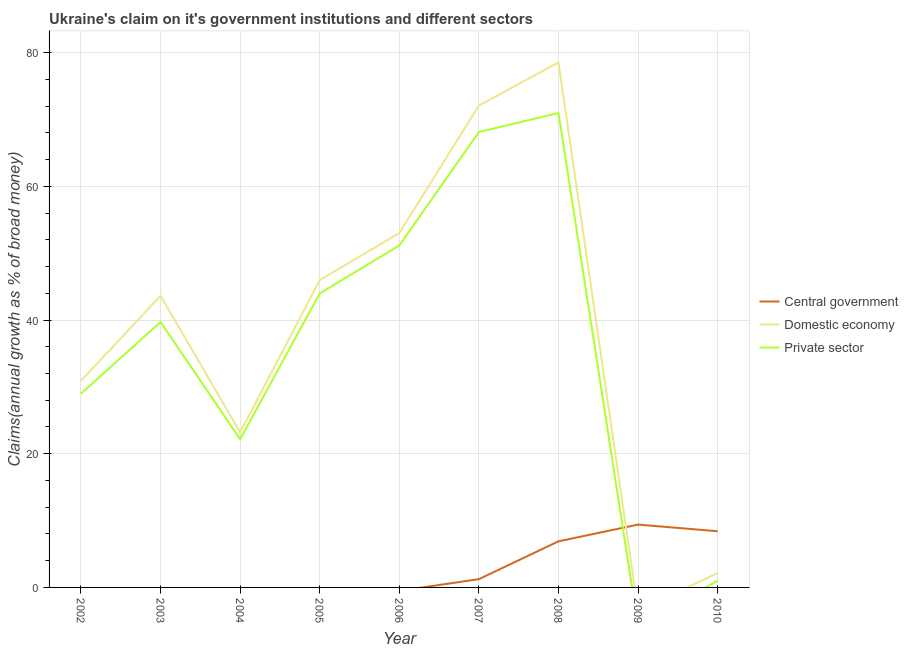How many different coloured lines are there?
Give a very brief answer. 3. Is the number of lines equal to the number of legend labels?
Your response must be concise. No. What is the percentage of claim on the private sector in 2008?
Provide a short and direct response. 70.97. Across all years, what is the maximum percentage of claim on the private sector?
Your response must be concise. 70.97. Across all years, what is the minimum percentage of claim on the central government?
Your answer should be compact. 0. In which year was the percentage of claim on the central government maximum?
Keep it short and to the point. 2009. What is the total percentage of claim on the private sector in the graph?
Offer a terse response. 326.09. What is the difference between the percentage of claim on the private sector in 2004 and that in 2008?
Offer a very short reply. -48.8. What is the difference between the percentage of claim on the central government in 2004 and the percentage of claim on the private sector in 2003?
Your answer should be compact. -39.7. What is the average percentage of claim on the central government per year?
Provide a short and direct response. 2.88. In the year 2008, what is the difference between the percentage of claim on the private sector and percentage of claim on the central government?
Make the answer very short. 64.07. In how many years, is the percentage of claim on the private sector greater than 44 %?
Provide a short and direct response. 3. What is the ratio of the percentage of claim on the domestic economy in 2002 to that in 2006?
Keep it short and to the point. 0.58. Is the percentage of claim on the private sector in 2003 less than that in 2004?
Offer a very short reply. No. Is the difference between the percentage of claim on the private sector in 2003 and 2005 greater than the difference between the percentage of claim on the domestic economy in 2003 and 2005?
Your response must be concise. No. What is the difference between the highest and the second highest percentage of claim on the private sector?
Provide a short and direct response. 2.84. What is the difference between the highest and the lowest percentage of claim on the private sector?
Offer a terse response. 70.97. In how many years, is the percentage of claim on the private sector greater than the average percentage of claim on the private sector taken over all years?
Make the answer very short. 5. Is it the case that in every year, the sum of the percentage of claim on the central government and percentage of claim on the domestic economy is greater than the percentage of claim on the private sector?
Ensure brevity in your answer.  Yes. How many lines are there?
Your answer should be very brief. 3. What is the difference between two consecutive major ticks on the Y-axis?
Ensure brevity in your answer.  20. Does the graph contain any zero values?
Offer a very short reply. Yes. How many legend labels are there?
Offer a terse response. 3. What is the title of the graph?
Make the answer very short. Ukraine's claim on it's government institutions and different sectors. What is the label or title of the Y-axis?
Your answer should be very brief. Claims(annual growth as % of broad money). What is the Claims(annual growth as % of broad money) of Domestic economy in 2002?
Keep it short and to the point. 30.9. What is the Claims(annual growth as % of broad money) in Private sector in 2002?
Provide a succinct answer. 28.98. What is the Claims(annual growth as % of broad money) of Central government in 2003?
Your answer should be very brief. 0. What is the Claims(annual growth as % of broad money) in Domestic economy in 2003?
Give a very brief answer. 43.63. What is the Claims(annual growth as % of broad money) of Private sector in 2003?
Your answer should be very brief. 39.7. What is the Claims(annual growth as % of broad money) in Central government in 2004?
Keep it short and to the point. 0. What is the Claims(annual growth as % of broad money) of Domestic economy in 2004?
Provide a short and direct response. 23.21. What is the Claims(annual growth as % of broad money) of Private sector in 2004?
Make the answer very short. 22.17. What is the Claims(annual growth as % of broad money) of Central government in 2005?
Keep it short and to the point. 0. What is the Claims(annual growth as % of broad money) of Domestic economy in 2005?
Ensure brevity in your answer.  45.97. What is the Claims(annual growth as % of broad money) of Private sector in 2005?
Offer a very short reply. 43.97. What is the Claims(annual growth as % of broad money) of Domestic economy in 2006?
Provide a short and direct response. 53. What is the Claims(annual growth as % of broad money) in Private sector in 2006?
Offer a terse response. 51.15. What is the Claims(annual growth as % of broad money) in Central government in 2007?
Your response must be concise. 1.24. What is the Claims(annual growth as % of broad money) in Domestic economy in 2007?
Offer a very short reply. 72.08. What is the Claims(annual growth as % of broad money) in Private sector in 2007?
Offer a terse response. 68.12. What is the Claims(annual growth as % of broad money) in Central government in 2008?
Your answer should be compact. 6.9. What is the Claims(annual growth as % of broad money) of Domestic economy in 2008?
Make the answer very short. 78.53. What is the Claims(annual growth as % of broad money) of Private sector in 2008?
Give a very brief answer. 70.97. What is the Claims(annual growth as % of broad money) of Central government in 2009?
Give a very brief answer. 9.4. What is the Claims(annual growth as % of broad money) of Private sector in 2009?
Your answer should be compact. 0. What is the Claims(annual growth as % of broad money) in Central government in 2010?
Ensure brevity in your answer.  8.4. What is the Claims(annual growth as % of broad money) of Domestic economy in 2010?
Provide a succinct answer. 2.14. What is the Claims(annual growth as % of broad money) in Private sector in 2010?
Offer a very short reply. 1.02. Across all years, what is the maximum Claims(annual growth as % of broad money) of Central government?
Offer a terse response. 9.4. Across all years, what is the maximum Claims(annual growth as % of broad money) in Domestic economy?
Offer a very short reply. 78.53. Across all years, what is the maximum Claims(annual growth as % of broad money) of Private sector?
Offer a terse response. 70.97. Across all years, what is the minimum Claims(annual growth as % of broad money) in Domestic economy?
Make the answer very short. 0. Across all years, what is the minimum Claims(annual growth as % of broad money) of Private sector?
Keep it short and to the point. 0. What is the total Claims(annual growth as % of broad money) of Central government in the graph?
Your answer should be compact. 25.94. What is the total Claims(annual growth as % of broad money) of Domestic economy in the graph?
Give a very brief answer. 349.46. What is the total Claims(annual growth as % of broad money) in Private sector in the graph?
Your response must be concise. 326.09. What is the difference between the Claims(annual growth as % of broad money) in Domestic economy in 2002 and that in 2003?
Provide a short and direct response. -12.72. What is the difference between the Claims(annual growth as % of broad money) of Private sector in 2002 and that in 2003?
Give a very brief answer. -10.72. What is the difference between the Claims(annual growth as % of broad money) in Domestic economy in 2002 and that in 2004?
Make the answer very short. 7.69. What is the difference between the Claims(annual growth as % of broad money) in Private sector in 2002 and that in 2004?
Provide a succinct answer. 6.82. What is the difference between the Claims(annual growth as % of broad money) of Domestic economy in 2002 and that in 2005?
Ensure brevity in your answer.  -15.06. What is the difference between the Claims(annual growth as % of broad money) of Private sector in 2002 and that in 2005?
Your response must be concise. -14.99. What is the difference between the Claims(annual growth as % of broad money) in Domestic economy in 2002 and that in 2006?
Your response must be concise. -22.1. What is the difference between the Claims(annual growth as % of broad money) of Private sector in 2002 and that in 2006?
Ensure brevity in your answer.  -22.17. What is the difference between the Claims(annual growth as % of broad money) in Domestic economy in 2002 and that in 2007?
Give a very brief answer. -41.18. What is the difference between the Claims(annual growth as % of broad money) in Private sector in 2002 and that in 2007?
Provide a succinct answer. -39.14. What is the difference between the Claims(annual growth as % of broad money) in Domestic economy in 2002 and that in 2008?
Provide a short and direct response. -47.62. What is the difference between the Claims(annual growth as % of broad money) of Private sector in 2002 and that in 2008?
Provide a short and direct response. -41.99. What is the difference between the Claims(annual growth as % of broad money) of Domestic economy in 2002 and that in 2010?
Your response must be concise. 28.76. What is the difference between the Claims(annual growth as % of broad money) in Private sector in 2002 and that in 2010?
Give a very brief answer. 27.96. What is the difference between the Claims(annual growth as % of broad money) in Domestic economy in 2003 and that in 2004?
Your response must be concise. 20.41. What is the difference between the Claims(annual growth as % of broad money) in Private sector in 2003 and that in 2004?
Your answer should be compact. 17.53. What is the difference between the Claims(annual growth as % of broad money) of Domestic economy in 2003 and that in 2005?
Ensure brevity in your answer.  -2.34. What is the difference between the Claims(annual growth as % of broad money) of Private sector in 2003 and that in 2005?
Offer a terse response. -4.27. What is the difference between the Claims(annual growth as % of broad money) in Domestic economy in 2003 and that in 2006?
Make the answer very short. -9.38. What is the difference between the Claims(annual growth as % of broad money) of Private sector in 2003 and that in 2006?
Make the answer very short. -11.45. What is the difference between the Claims(annual growth as % of broad money) in Domestic economy in 2003 and that in 2007?
Offer a terse response. -28.45. What is the difference between the Claims(annual growth as % of broad money) of Private sector in 2003 and that in 2007?
Make the answer very short. -28.42. What is the difference between the Claims(annual growth as % of broad money) of Domestic economy in 2003 and that in 2008?
Offer a very short reply. -34.9. What is the difference between the Claims(annual growth as % of broad money) in Private sector in 2003 and that in 2008?
Provide a succinct answer. -31.27. What is the difference between the Claims(annual growth as % of broad money) in Domestic economy in 2003 and that in 2010?
Your answer should be compact. 41.49. What is the difference between the Claims(annual growth as % of broad money) in Private sector in 2003 and that in 2010?
Ensure brevity in your answer.  38.68. What is the difference between the Claims(annual growth as % of broad money) in Domestic economy in 2004 and that in 2005?
Your answer should be very brief. -22.75. What is the difference between the Claims(annual growth as % of broad money) in Private sector in 2004 and that in 2005?
Offer a terse response. -21.81. What is the difference between the Claims(annual growth as % of broad money) of Domestic economy in 2004 and that in 2006?
Keep it short and to the point. -29.79. What is the difference between the Claims(annual growth as % of broad money) in Private sector in 2004 and that in 2006?
Your response must be concise. -28.98. What is the difference between the Claims(annual growth as % of broad money) in Domestic economy in 2004 and that in 2007?
Offer a very short reply. -48.86. What is the difference between the Claims(annual growth as % of broad money) of Private sector in 2004 and that in 2007?
Make the answer very short. -45.96. What is the difference between the Claims(annual growth as % of broad money) of Domestic economy in 2004 and that in 2008?
Make the answer very short. -55.31. What is the difference between the Claims(annual growth as % of broad money) of Private sector in 2004 and that in 2008?
Provide a succinct answer. -48.8. What is the difference between the Claims(annual growth as % of broad money) of Domestic economy in 2004 and that in 2010?
Ensure brevity in your answer.  21.07. What is the difference between the Claims(annual growth as % of broad money) in Private sector in 2004 and that in 2010?
Ensure brevity in your answer.  21.15. What is the difference between the Claims(annual growth as % of broad money) of Domestic economy in 2005 and that in 2006?
Make the answer very short. -7.04. What is the difference between the Claims(annual growth as % of broad money) of Private sector in 2005 and that in 2006?
Offer a terse response. -7.17. What is the difference between the Claims(annual growth as % of broad money) of Domestic economy in 2005 and that in 2007?
Your response must be concise. -26.11. What is the difference between the Claims(annual growth as % of broad money) of Private sector in 2005 and that in 2007?
Provide a short and direct response. -24.15. What is the difference between the Claims(annual growth as % of broad money) of Domestic economy in 2005 and that in 2008?
Ensure brevity in your answer.  -32.56. What is the difference between the Claims(annual growth as % of broad money) in Private sector in 2005 and that in 2008?
Provide a short and direct response. -26.99. What is the difference between the Claims(annual growth as % of broad money) in Domestic economy in 2005 and that in 2010?
Keep it short and to the point. 43.83. What is the difference between the Claims(annual growth as % of broad money) of Private sector in 2005 and that in 2010?
Give a very brief answer. 42.96. What is the difference between the Claims(annual growth as % of broad money) in Domestic economy in 2006 and that in 2007?
Ensure brevity in your answer.  -19.07. What is the difference between the Claims(annual growth as % of broad money) in Private sector in 2006 and that in 2007?
Your answer should be compact. -16.97. What is the difference between the Claims(annual growth as % of broad money) in Domestic economy in 2006 and that in 2008?
Make the answer very short. -25.52. What is the difference between the Claims(annual growth as % of broad money) in Private sector in 2006 and that in 2008?
Your answer should be compact. -19.82. What is the difference between the Claims(annual growth as % of broad money) in Domestic economy in 2006 and that in 2010?
Your response must be concise. 50.87. What is the difference between the Claims(annual growth as % of broad money) in Private sector in 2006 and that in 2010?
Provide a succinct answer. 50.13. What is the difference between the Claims(annual growth as % of broad money) of Central government in 2007 and that in 2008?
Offer a very short reply. -5.66. What is the difference between the Claims(annual growth as % of broad money) of Domestic economy in 2007 and that in 2008?
Offer a very short reply. -6.45. What is the difference between the Claims(annual growth as % of broad money) in Private sector in 2007 and that in 2008?
Your answer should be very brief. -2.84. What is the difference between the Claims(annual growth as % of broad money) of Central government in 2007 and that in 2009?
Ensure brevity in your answer.  -8.16. What is the difference between the Claims(annual growth as % of broad money) in Central government in 2007 and that in 2010?
Offer a very short reply. -7.17. What is the difference between the Claims(annual growth as % of broad money) of Domestic economy in 2007 and that in 2010?
Give a very brief answer. 69.94. What is the difference between the Claims(annual growth as % of broad money) of Private sector in 2007 and that in 2010?
Offer a very short reply. 67.11. What is the difference between the Claims(annual growth as % of broad money) of Central government in 2008 and that in 2009?
Offer a very short reply. -2.51. What is the difference between the Claims(annual growth as % of broad money) in Central government in 2008 and that in 2010?
Offer a terse response. -1.51. What is the difference between the Claims(annual growth as % of broad money) of Domestic economy in 2008 and that in 2010?
Offer a terse response. 76.39. What is the difference between the Claims(annual growth as % of broad money) of Private sector in 2008 and that in 2010?
Your answer should be compact. 69.95. What is the difference between the Claims(annual growth as % of broad money) of Central government in 2009 and that in 2010?
Your answer should be very brief. 1. What is the difference between the Claims(annual growth as % of broad money) of Domestic economy in 2002 and the Claims(annual growth as % of broad money) of Private sector in 2003?
Offer a very short reply. -8.8. What is the difference between the Claims(annual growth as % of broad money) in Domestic economy in 2002 and the Claims(annual growth as % of broad money) in Private sector in 2004?
Your response must be concise. 8.74. What is the difference between the Claims(annual growth as % of broad money) in Domestic economy in 2002 and the Claims(annual growth as % of broad money) in Private sector in 2005?
Provide a short and direct response. -13.07. What is the difference between the Claims(annual growth as % of broad money) in Domestic economy in 2002 and the Claims(annual growth as % of broad money) in Private sector in 2006?
Keep it short and to the point. -20.25. What is the difference between the Claims(annual growth as % of broad money) in Domestic economy in 2002 and the Claims(annual growth as % of broad money) in Private sector in 2007?
Offer a very short reply. -37.22. What is the difference between the Claims(annual growth as % of broad money) of Domestic economy in 2002 and the Claims(annual growth as % of broad money) of Private sector in 2008?
Make the answer very short. -40.07. What is the difference between the Claims(annual growth as % of broad money) of Domestic economy in 2002 and the Claims(annual growth as % of broad money) of Private sector in 2010?
Offer a terse response. 29.88. What is the difference between the Claims(annual growth as % of broad money) in Domestic economy in 2003 and the Claims(annual growth as % of broad money) in Private sector in 2004?
Offer a very short reply. 21.46. What is the difference between the Claims(annual growth as % of broad money) in Domestic economy in 2003 and the Claims(annual growth as % of broad money) in Private sector in 2005?
Your answer should be compact. -0.35. What is the difference between the Claims(annual growth as % of broad money) in Domestic economy in 2003 and the Claims(annual growth as % of broad money) in Private sector in 2006?
Offer a very short reply. -7.52. What is the difference between the Claims(annual growth as % of broad money) of Domestic economy in 2003 and the Claims(annual growth as % of broad money) of Private sector in 2007?
Give a very brief answer. -24.5. What is the difference between the Claims(annual growth as % of broad money) of Domestic economy in 2003 and the Claims(annual growth as % of broad money) of Private sector in 2008?
Give a very brief answer. -27.34. What is the difference between the Claims(annual growth as % of broad money) of Domestic economy in 2003 and the Claims(annual growth as % of broad money) of Private sector in 2010?
Offer a terse response. 42.61. What is the difference between the Claims(annual growth as % of broad money) of Domestic economy in 2004 and the Claims(annual growth as % of broad money) of Private sector in 2005?
Your response must be concise. -20.76. What is the difference between the Claims(annual growth as % of broad money) of Domestic economy in 2004 and the Claims(annual growth as % of broad money) of Private sector in 2006?
Make the answer very short. -27.94. What is the difference between the Claims(annual growth as % of broad money) of Domestic economy in 2004 and the Claims(annual growth as % of broad money) of Private sector in 2007?
Give a very brief answer. -44.91. What is the difference between the Claims(annual growth as % of broad money) in Domestic economy in 2004 and the Claims(annual growth as % of broad money) in Private sector in 2008?
Offer a terse response. -47.75. What is the difference between the Claims(annual growth as % of broad money) in Domestic economy in 2004 and the Claims(annual growth as % of broad money) in Private sector in 2010?
Ensure brevity in your answer.  22.2. What is the difference between the Claims(annual growth as % of broad money) in Domestic economy in 2005 and the Claims(annual growth as % of broad money) in Private sector in 2006?
Ensure brevity in your answer.  -5.18. What is the difference between the Claims(annual growth as % of broad money) of Domestic economy in 2005 and the Claims(annual growth as % of broad money) of Private sector in 2007?
Offer a very short reply. -22.16. What is the difference between the Claims(annual growth as % of broad money) in Domestic economy in 2005 and the Claims(annual growth as % of broad money) in Private sector in 2008?
Your answer should be compact. -25. What is the difference between the Claims(annual growth as % of broad money) in Domestic economy in 2005 and the Claims(annual growth as % of broad money) in Private sector in 2010?
Keep it short and to the point. 44.95. What is the difference between the Claims(annual growth as % of broad money) in Domestic economy in 2006 and the Claims(annual growth as % of broad money) in Private sector in 2007?
Your answer should be compact. -15.12. What is the difference between the Claims(annual growth as % of broad money) in Domestic economy in 2006 and the Claims(annual growth as % of broad money) in Private sector in 2008?
Offer a very short reply. -17.96. What is the difference between the Claims(annual growth as % of broad money) in Domestic economy in 2006 and the Claims(annual growth as % of broad money) in Private sector in 2010?
Give a very brief answer. 51.99. What is the difference between the Claims(annual growth as % of broad money) in Central government in 2007 and the Claims(annual growth as % of broad money) in Domestic economy in 2008?
Provide a succinct answer. -77.29. What is the difference between the Claims(annual growth as % of broad money) of Central government in 2007 and the Claims(annual growth as % of broad money) of Private sector in 2008?
Keep it short and to the point. -69.73. What is the difference between the Claims(annual growth as % of broad money) in Domestic economy in 2007 and the Claims(annual growth as % of broad money) in Private sector in 2008?
Your response must be concise. 1.11. What is the difference between the Claims(annual growth as % of broad money) of Central government in 2007 and the Claims(annual growth as % of broad money) of Domestic economy in 2010?
Your answer should be compact. -0.9. What is the difference between the Claims(annual growth as % of broad money) of Central government in 2007 and the Claims(annual growth as % of broad money) of Private sector in 2010?
Your response must be concise. 0.22. What is the difference between the Claims(annual growth as % of broad money) in Domestic economy in 2007 and the Claims(annual growth as % of broad money) in Private sector in 2010?
Offer a terse response. 71.06. What is the difference between the Claims(annual growth as % of broad money) of Central government in 2008 and the Claims(annual growth as % of broad money) of Domestic economy in 2010?
Keep it short and to the point. 4.76. What is the difference between the Claims(annual growth as % of broad money) in Central government in 2008 and the Claims(annual growth as % of broad money) in Private sector in 2010?
Make the answer very short. 5.88. What is the difference between the Claims(annual growth as % of broad money) of Domestic economy in 2008 and the Claims(annual growth as % of broad money) of Private sector in 2010?
Provide a short and direct response. 77.51. What is the difference between the Claims(annual growth as % of broad money) of Central government in 2009 and the Claims(annual growth as % of broad money) of Domestic economy in 2010?
Provide a short and direct response. 7.26. What is the difference between the Claims(annual growth as % of broad money) of Central government in 2009 and the Claims(annual growth as % of broad money) of Private sector in 2010?
Offer a terse response. 8.38. What is the average Claims(annual growth as % of broad money) in Central government per year?
Make the answer very short. 2.88. What is the average Claims(annual growth as % of broad money) in Domestic economy per year?
Your answer should be compact. 38.83. What is the average Claims(annual growth as % of broad money) of Private sector per year?
Keep it short and to the point. 36.23. In the year 2002, what is the difference between the Claims(annual growth as % of broad money) of Domestic economy and Claims(annual growth as % of broad money) of Private sector?
Provide a short and direct response. 1.92. In the year 2003, what is the difference between the Claims(annual growth as % of broad money) of Domestic economy and Claims(annual growth as % of broad money) of Private sector?
Your answer should be very brief. 3.92. In the year 2004, what is the difference between the Claims(annual growth as % of broad money) in Domestic economy and Claims(annual growth as % of broad money) in Private sector?
Offer a very short reply. 1.05. In the year 2005, what is the difference between the Claims(annual growth as % of broad money) of Domestic economy and Claims(annual growth as % of broad money) of Private sector?
Your answer should be very brief. 1.99. In the year 2006, what is the difference between the Claims(annual growth as % of broad money) in Domestic economy and Claims(annual growth as % of broad money) in Private sector?
Provide a short and direct response. 1.86. In the year 2007, what is the difference between the Claims(annual growth as % of broad money) in Central government and Claims(annual growth as % of broad money) in Domestic economy?
Give a very brief answer. -70.84. In the year 2007, what is the difference between the Claims(annual growth as % of broad money) of Central government and Claims(annual growth as % of broad money) of Private sector?
Offer a very short reply. -66.89. In the year 2007, what is the difference between the Claims(annual growth as % of broad money) in Domestic economy and Claims(annual growth as % of broad money) in Private sector?
Offer a very short reply. 3.95. In the year 2008, what is the difference between the Claims(annual growth as % of broad money) of Central government and Claims(annual growth as % of broad money) of Domestic economy?
Your response must be concise. -71.63. In the year 2008, what is the difference between the Claims(annual growth as % of broad money) in Central government and Claims(annual growth as % of broad money) in Private sector?
Your response must be concise. -64.07. In the year 2008, what is the difference between the Claims(annual growth as % of broad money) of Domestic economy and Claims(annual growth as % of broad money) of Private sector?
Make the answer very short. 7.56. In the year 2010, what is the difference between the Claims(annual growth as % of broad money) in Central government and Claims(annual growth as % of broad money) in Domestic economy?
Keep it short and to the point. 6.26. In the year 2010, what is the difference between the Claims(annual growth as % of broad money) in Central government and Claims(annual growth as % of broad money) in Private sector?
Keep it short and to the point. 7.38. In the year 2010, what is the difference between the Claims(annual growth as % of broad money) in Domestic economy and Claims(annual growth as % of broad money) in Private sector?
Give a very brief answer. 1.12. What is the ratio of the Claims(annual growth as % of broad money) in Domestic economy in 2002 to that in 2003?
Provide a short and direct response. 0.71. What is the ratio of the Claims(annual growth as % of broad money) in Private sector in 2002 to that in 2003?
Provide a short and direct response. 0.73. What is the ratio of the Claims(annual growth as % of broad money) in Domestic economy in 2002 to that in 2004?
Your answer should be very brief. 1.33. What is the ratio of the Claims(annual growth as % of broad money) in Private sector in 2002 to that in 2004?
Provide a short and direct response. 1.31. What is the ratio of the Claims(annual growth as % of broad money) in Domestic economy in 2002 to that in 2005?
Offer a very short reply. 0.67. What is the ratio of the Claims(annual growth as % of broad money) in Private sector in 2002 to that in 2005?
Offer a terse response. 0.66. What is the ratio of the Claims(annual growth as % of broad money) of Domestic economy in 2002 to that in 2006?
Your answer should be very brief. 0.58. What is the ratio of the Claims(annual growth as % of broad money) of Private sector in 2002 to that in 2006?
Your answer should be compact. 0.57. What is the ratio of the Claims(annual growth as % of broad money) in Domestic economy in 2002 to that in 2007?
Make the answer very short. 0.43. What is the ratio of the Claims(annual growth as % of broad money) of Private sector in 2002 to that in 2007?
Offer a very short reply. 0.43. What is the ratio of the Claims(annual growth as % of broad money) of Domestic economy in 2002 to that in 2008?
Your answer should be very brief. 0.39. What is the ratio of the Claims(annual growth as % of broad money) in Private sector in 2002 to that in 2008?
Offer a terse response. 0.41. What is the ratio of the Claims(annual growth as % of broad money) of Domestic economy in 2002 to that in 2010?
Your answer should be very brief. 14.45. What is the ratio of the Claims(annual growth as % of broad money) in Private sector in 2002 to that in 2010?
Offer a terse response. 28.45. What is the ratio of the Claims(annual growth as % of broad money) of Domestic economy in 2003 to that in 2004?
Ensure brevity in your answer.  1.88. What is the ratio of the Claims(annual growth as % of broad money) in Private sector in 2003 to that in 2004?
Ensure brevity in your answer.  1.79. What is the ratio of the Claims(annual growth as % of broad money) in Domestic economy in 2003 to that in 2005?
Your response must be concise. 0.95. What is the ratio of the Claims(annual growth as % of broad money) of Private sector in 2003 to that in 2005?
Provide a short and direct response. 0.9. What is the ratio of the Claims(annual growth as % of broad money) of Domestic economy in 2003 to that in 2006?
Make the answer very short. 0.82. What is the ratio of the Claims(annual growth as % of broad money) of Private sector in 2003 to that in 2006?
Provide a short and direct response. 0.78. What is the ratio of the Claims(annual growth as % of broad money) of Domestic economy in 2003 to that in 2007?
Give a very brief answer. 0.61. What is the ratio of the Claims(annual growth as % of broad money) of Private sector in 2003 to that in 2007?
Ensure brevity in your answer.  0.58. What is the ratio of the Claims(annual growth as % of broad money) of Domestic economy in 2003 to that in 2008?
Offer a very short reply. 0.56. What is the ratio of the Claims(annual growth as % of broad money) in Private sector in 2003 to that in 2008?
Keep it short and to the point. 0.56. What is the ratio of the Claims(annual growth as % of broad money) of Domestic economy in 2003 to that in 2010?
Your response must be concise. 20.39. What is the ratio of the Claims(annual growth as % of broad money) in Private sector in 2003 to that in 2010?
Provide a succinct answer. 38.97. What is the ratio of the Claims(annual growth as % of broad money) of Domestic economy in 2004 to that in 2005?
Your answer should be very brief. 0.51. What is the ratio of the Claims(annual growth as % of broad money) of Private sector in 2004 to that in 2005?
Provide a short and direct response. 0.5. What is the ratio of the Claims(annual growth as % of broad money) in Domestic economy in 2004 to that in 2006?
Keep it short and to the point. 0.44. What is the ratio of the Claims(annual growth as % of broad money) of Private sector in 2004 to that in 2006?
Provide a succinct answer. 0.43. What is the ratio of the Claims(annual growth as % of broad money) of Domestic economy in 2004 to that in 2007?
Keep it short and to the point. 0.32. What is the ratio of the Claims(annual growth as % of broad money) of Private sector in 2004 to that in 2007?
Offer a terse response. 0.33. What is the ratio of the Claims(annual growth as % of broad money) in Domestic economy in 2004 to that in 2008?
Your answer should be compact. 0.3. What is the ratio of the Claims(annual growth as % of broad money) of Private sector in 2004 to that in 2008?
Give a very brief answer. 0.31. What is the ratio of the Claims(annual growth as % of broad money) in Domestic economy in 2004 to that in 2010?
Your answer should be very brief. 10.85. What is the ratio of the Claims(annual growth as % of broad money) of Private sector in 2004 to that in 2010?
Offer a very short reply. 21.76. What is the ratio of the Claims(annual growth as % of broad money) of Domestic economy in 2005 to that in 2006?
Provide a short and direct response. 0.87. What is the ratio of the Claims(annual growth as % of broad money) of Private sector in 2005 to that in 2006?
Provide a short and direct response. 0.86. What is the ratio of the Claims(annual growth as % of broad money) of Domestic economy in 2005 to that in 2007?
Provide a succinct answer. 0.64. What is the ratio of the Claims(annual growth as % of broad money) of Private sector in 2005 to that in 2007?
Provide a short and direct response. 0.65. What is the ratio of the Claims(annual growth as % of broad money) in Domestic economy in 2005 to that in 2008?
Your answer should be compact. 0.59. What is the ratio of the Claims(annual growth as % of broad money) in Private sector in 2005 to that in 2008?
Offer a terse response. 0.62. What is the ratio of the Claims(annual growth as % of broad money) of Domestic economy in 2005 to that in 2010?
Your answer should be compact. 21.49. What is the ratio of the Claims(annual growth as % of broad money) of Private sector in 2005 to that in 2010?
Offer a terse response. 43.16. What is the ratio of the Claims(annual growth as % of broad money) of Domestic economy in 2006 to that in 2007?
Make the answer very short. 0.74. What is the ratio of the Claims(annual growth as % of broad money) of Private sector in 2006 to that in 2007?
Provide a succinct answer. 0.75. What is the ratio of the Claims(annual growth as % of broad money) of Domestic economy in 2006 to that in 2008?
Provide a succinct answer. 0.68. What is the ratio of the Claims(annual growth as % of broad money) in Private sector in 2006 to that in 2008?
Your response must be concise. 0.72. What is the ratio of the Claims(annual growth as % of broad money) in Domestic economy in 2006 to that in 2010?
Offer a very short reply. 24.78. What is the ratio of the Claims(annual growth as % of broad money) of Private sector in 2006 to that in 2010?
Give a very brief answer. 50.2. What is the ratio of the Claims(annual growth as % of broad money) of Central government in 2007 to that in 2008?
Provide a succinct answer. 0.18. What is the ratio of the Claims(annual growth as % of broad money) of Domestic economy in 2007 to that in 2008?
Your response must be concise. 0.92. What is the ratio of the Claims(annual growth as % of broad money) in Private sector in 2007 to that in 2008?
Offer a very short reply. 0.96. What is the ratio of the Claims(annual growth as % of broad money) of Central government in 2007 to that in 2009?
Offer a very short reply. 0.13. What is the ratio of the Claims(annual growth as % of broad money) in Central government in 2007 to that in 2010?
Offer a terse response. 0.15. What is the ratio of the Claims(annual growth as % of broad money) in Domestic economy in 2007 to that in 2010?
Provide a succinct answer. 33.69. What is the ratio of the Claims(annual growth as % of broad money) of Private sector in 2007 to that in 2010?
Ensure brevity in your answer.  66.87. What is the ratio of the Claims(annual growth as % of broad money) in Central government in 2008 to that in 2009?
Make the answer very short. 0.73. What is the ratio of the Claims(annual growth as % of broad money) in Central government in 2008 to that in 2010?
Your response must be concise. 0.82. What is the ratio of the Claims(annual growth as % of broad money) of Domestic economy in 2008 to that in 2010?
Keep it short and to the point. 36.71. What is the ratio of the Claims(annual growth as % of broad money) in Private sector in 2008 to that in 2010?
Your answer should be very brief. 69.66. What is the ratio of the Claims(annual growth as % of broad money) of Central government in 2009 to that in 2010?
Give a very brief answer. 1.12. What is the difference between the highest and the second highest Claims(annual growth as % of broad money) of Domestic economy?
Ensure brevity in your answer.  6.45. What is the difference between the highest and the second highest Claims(annual growth as % of broad money) in Private sector?
Your response must be concise. 2.84. What is the difference between the highest and the lowest Claims(annual growth as % of broad money) of Central government?
Make the answer very short. 9.4. What is the difference between the highest and the lowest Claims(annual growth as % of broad money) of Domestic economy?
Provide a succinct answer. 78.53. What is the difference between the highest and the lowest Claims(annual growth as % of broad money) of Private sector?
Offer a terse response. 70.97. 